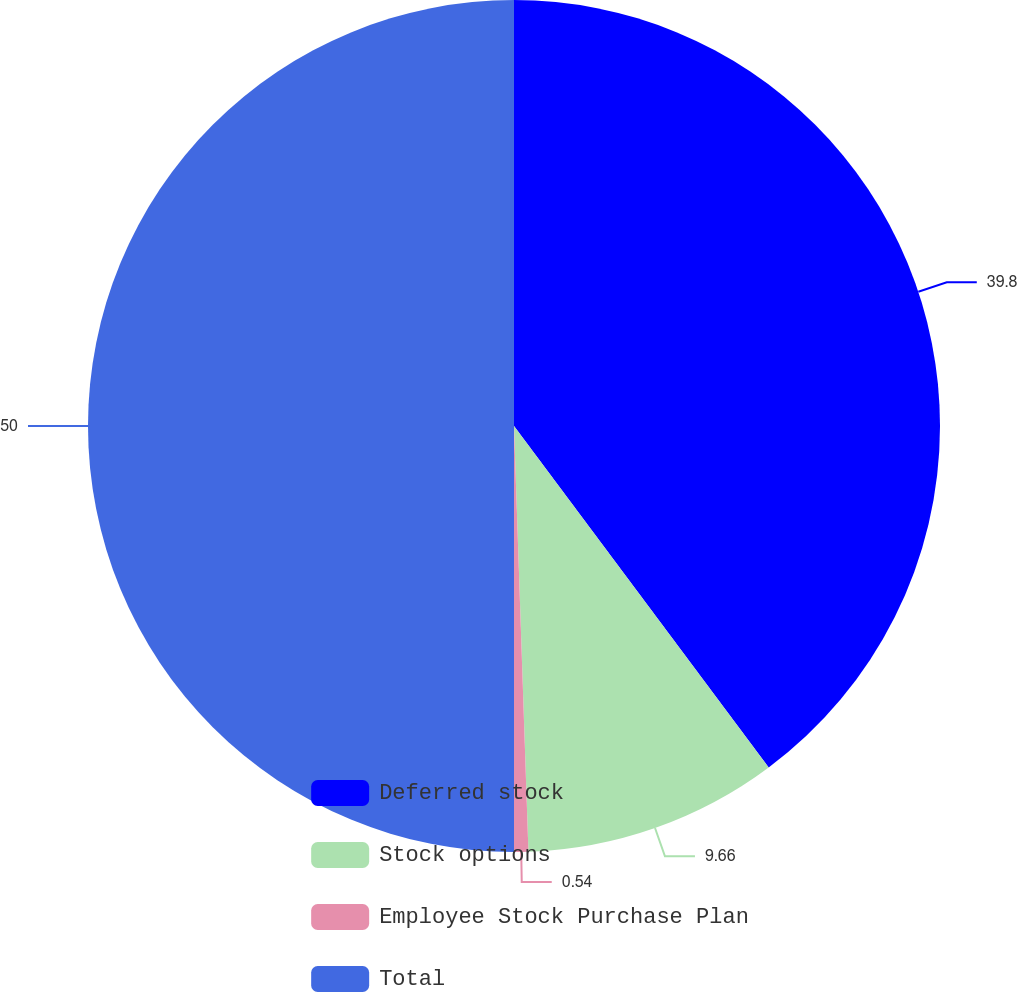Convert chart to OTSL. <chart><loc_0><loc_0><loc_500><loc_500><pie_chart><fcel>Deferred stock<fcel>Stock options<fcel>Employee Stock Purchase Plan<fcel>Total<nl><fcel>39.8%<fcel>9.66%<fcel>0.54%<fcel>50.0%<nl></chart> 